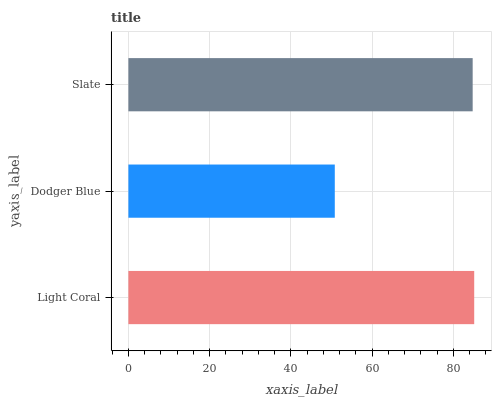Is Dodger Blue the minimum?
Answer yes or no. Yes. Is Light Coral the maximum?
Answer yes or no. Yes. Is Slate the minimum?
Answer yes or no. No. Is Slate the maximum?
Answer yes or no. No. Is Slate greater than Dodger Blue?
Answer yes or no. Yes. Is Dodger Blue less than Slate?
Answer yes or no. Yes. Is Dodger Blue greater than Slate?
Answer yes or no. No. Is Slate less than Dodger Blue?
Answer yes or no. No. Is Slate the high median?
Answer yes or no. Yes. Is Slate the low median?
Answer yes or no. Yes. Is Dodger Blue the high median?
Answer yes or no. No. Is Dodger Blue the low median?
Answer yes or no. No. 